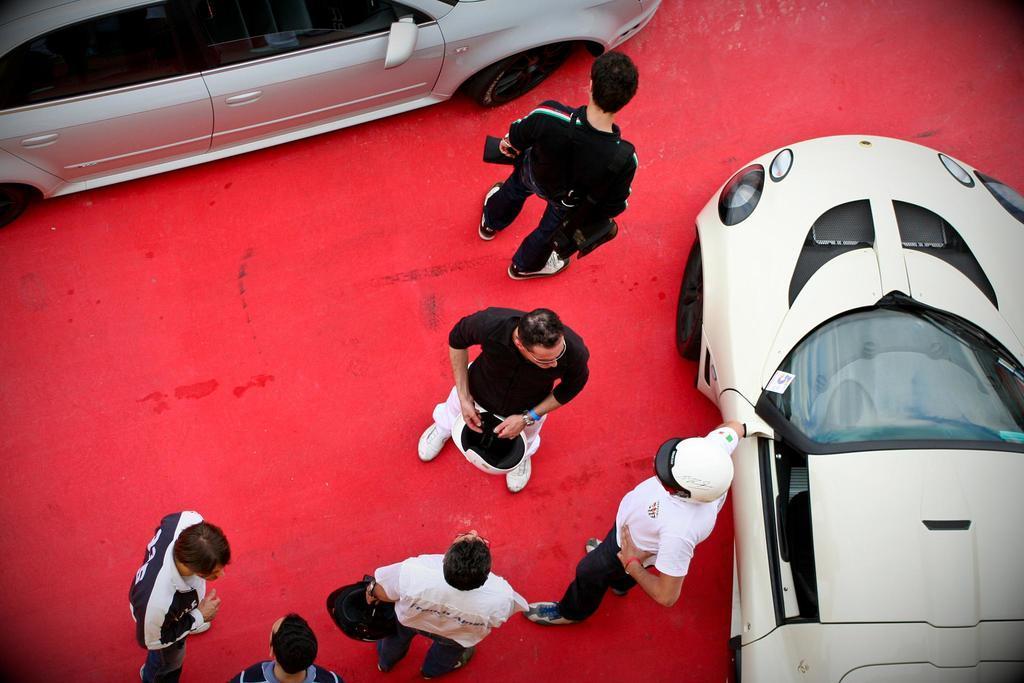In one or two sentences, can you explain what this image depicts? This picture describes about group of people, they are standing on the red color carpet, beside to them we can see few cars. 